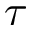<formula> <loc_0><loc_0><loc_500><loc_500>\tau</formula> 